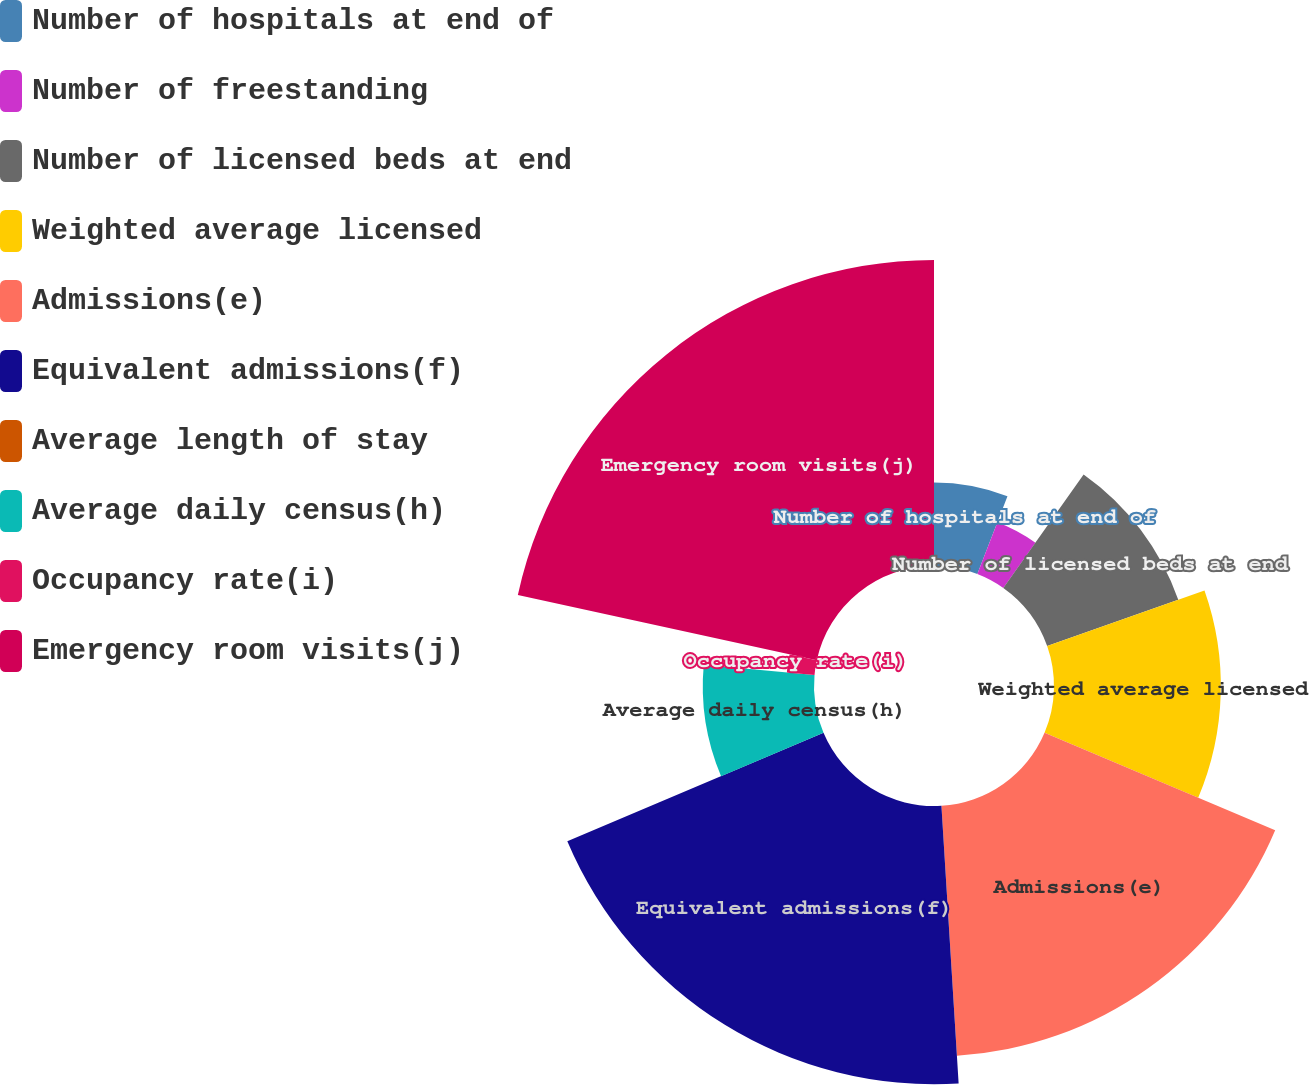<chart> <loc_0><loc_0><loc_500><loc_500><pie_chart><fcel>Number of hospitals at end of<fcel>Number of freestanding<fcel>Number of licensed beds at end<fcel>Weighted average licensed<fcel>Admissions(e)<fcel>Equivalent admissions(f)<fcel>Average length of stay<fcel>Average daily census(h)<fcel>Occupancy rate(i)<fcel>Emergency room visits(j)<nl><fcel>5.88%<fcel>3.92%<fcel>9.8%<fcel>11.76%<fcel>17.65%<fcel>19.61%<fcel>0.0%<fcel>7.84%<fcel>1.96%<fcel>21.57%<nl></chart> 